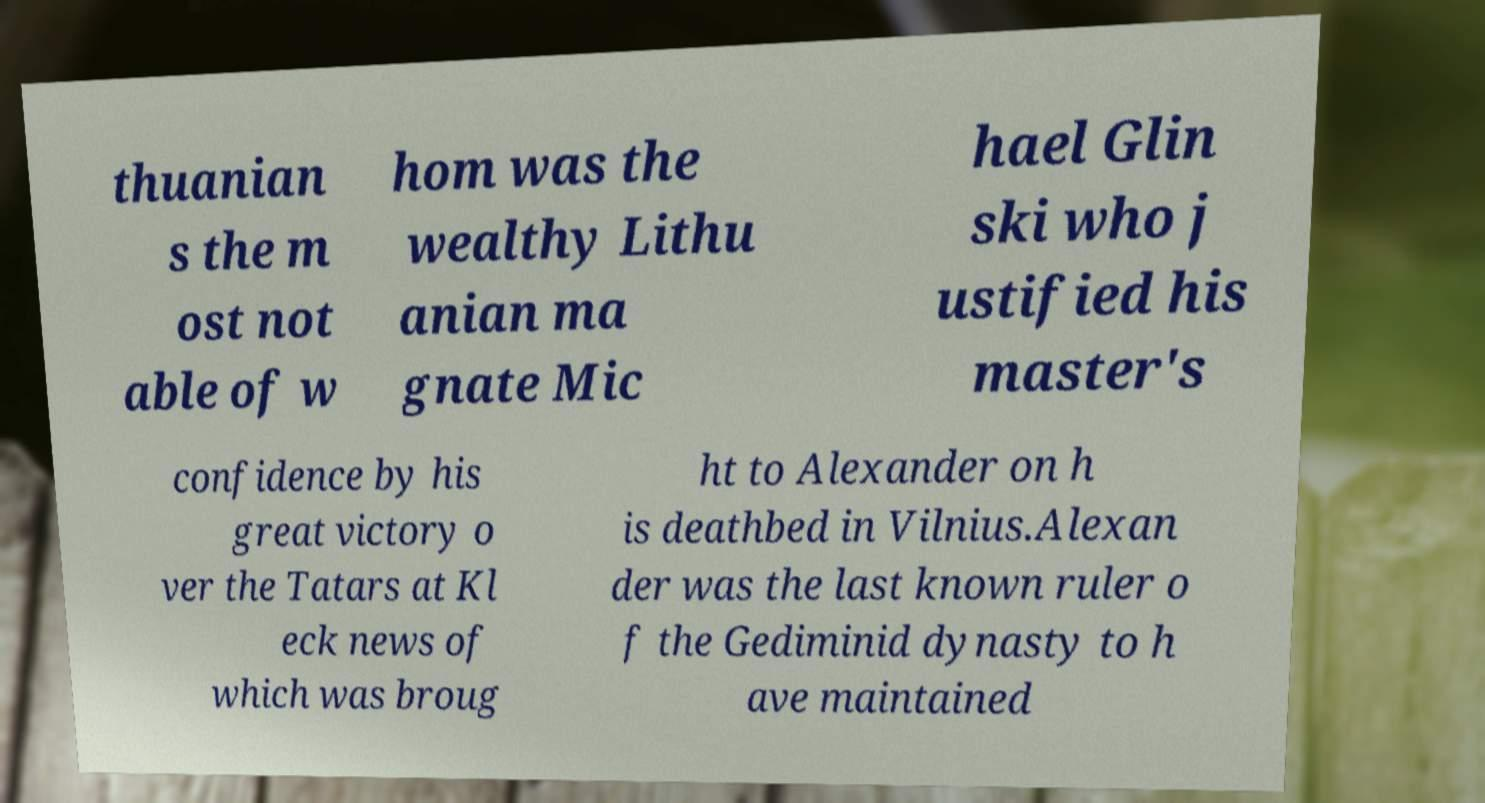What messages or text are displayed in this image? I need them in a readable, typed format. thuanian s the m ost not able of w hom was the wealthy Lithu anian ma gnate Mic hael Glin ski who j ustified his master's confidence by his great victory o ver the Tatars at Kl eck news of which was broug ht to Alexander on h is deathbed in Vilnius.Alexan der was the last known ruler o f the Gediminid dynasty to h ave maintained 